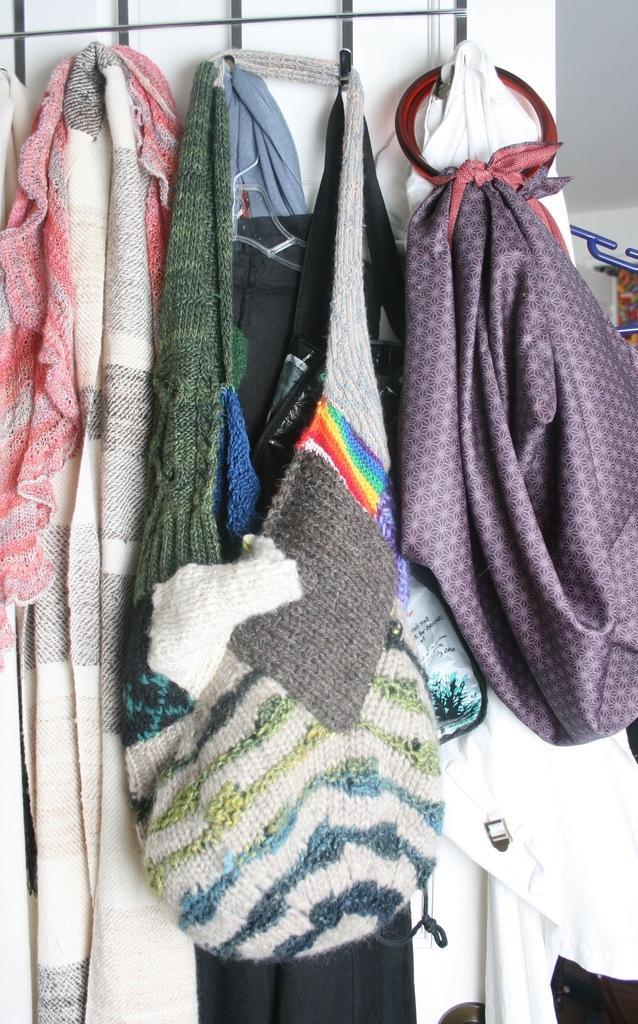How would you summarize this image in a sentence or two? In this picture I can see clothes hanging to the clothes hanger, and in the background there is a wall. 